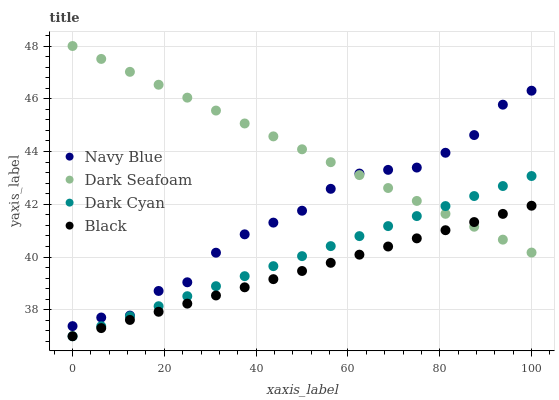Does Black have the minimum area under the curve?
Answer yes or no. Yes. Does Dark Seafoam have the maximum area under the curve?
Answer yes or no. Yes. Does Navy Blue have the minimum area under the curve?
Answer yes or no. No. Does Navy Blue have the maximum area under the curve?
Answer yes or no. No. Is Dark Cyan the smoothest?
Answer yes or no. Yes. Is Navy Blue the roughest?
Answer yes or no. Yes. Is Dark Seafoam the smoothest?
Answer yes or no. No. Is Dark Seafoam the roughest?
Answer yes or no. No. Does Dark Cyan have the lowest value?
Answer yes or no. Yes. Does Navy Blue have the lowest value?
Answer yes or no. No. Does Dark Seafoam have the highest value?
Answer yes or no. Yes. Does Navy Blue have the highest value?
Answer yes or no. No. Is Dark Cyan less than Navy Blue?
Answer yes or no. Yes. Is Navy Blue greater than Dark Cyan?
Answer yes or no. Yes. Does Dark Seafoam intersect Black?
Answer yes or no. Yes. Is Dark Seafoam less than Black?
Answer yes or no. No. Is Dark Seafoam greater than Black?
Answer yes or no. No. Does Dark Cyan intersect Navy Blue?
Answer yes or no. No. 